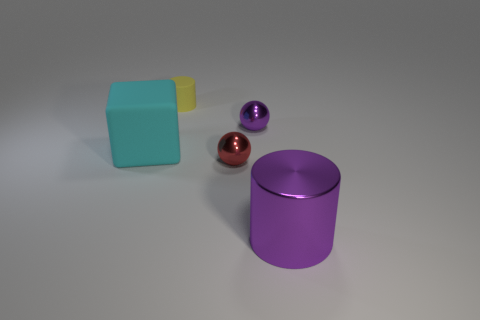What material is the tiny object in front of the cyan rubber block?
Provide a succinct answer. Metal. Do the yellow object and the red object have the same shape?
Your answer should be compact. No. Is there any other thing of the same color as the large matte block?
Your answer should be compact. No. What color is the other metal object that is the same shape as the red thing?
Provide a succinct answer. Purple. Is the number of purple metal spheres on the right side of the large purple metal cylinder greater than the number of big metal cylinders?
Offer a terse response. No. There is a thing that is behind the purple metallic sphere; what is its color?
Your response must be concise. Yellow. Does the purple metallic cylinder have the same size as the cyan rubber object?
Ensure brevity in your answer.  Yes. The matte block is what size?
Offer a terse response. Large. The shiny object that is the same color as the big cylinder is what shape?
Offer a very short reply. Sphere. Is the number of tiny yellow matte things greater than the number of yellow matte balls?
Offer a terse response. Yes. 